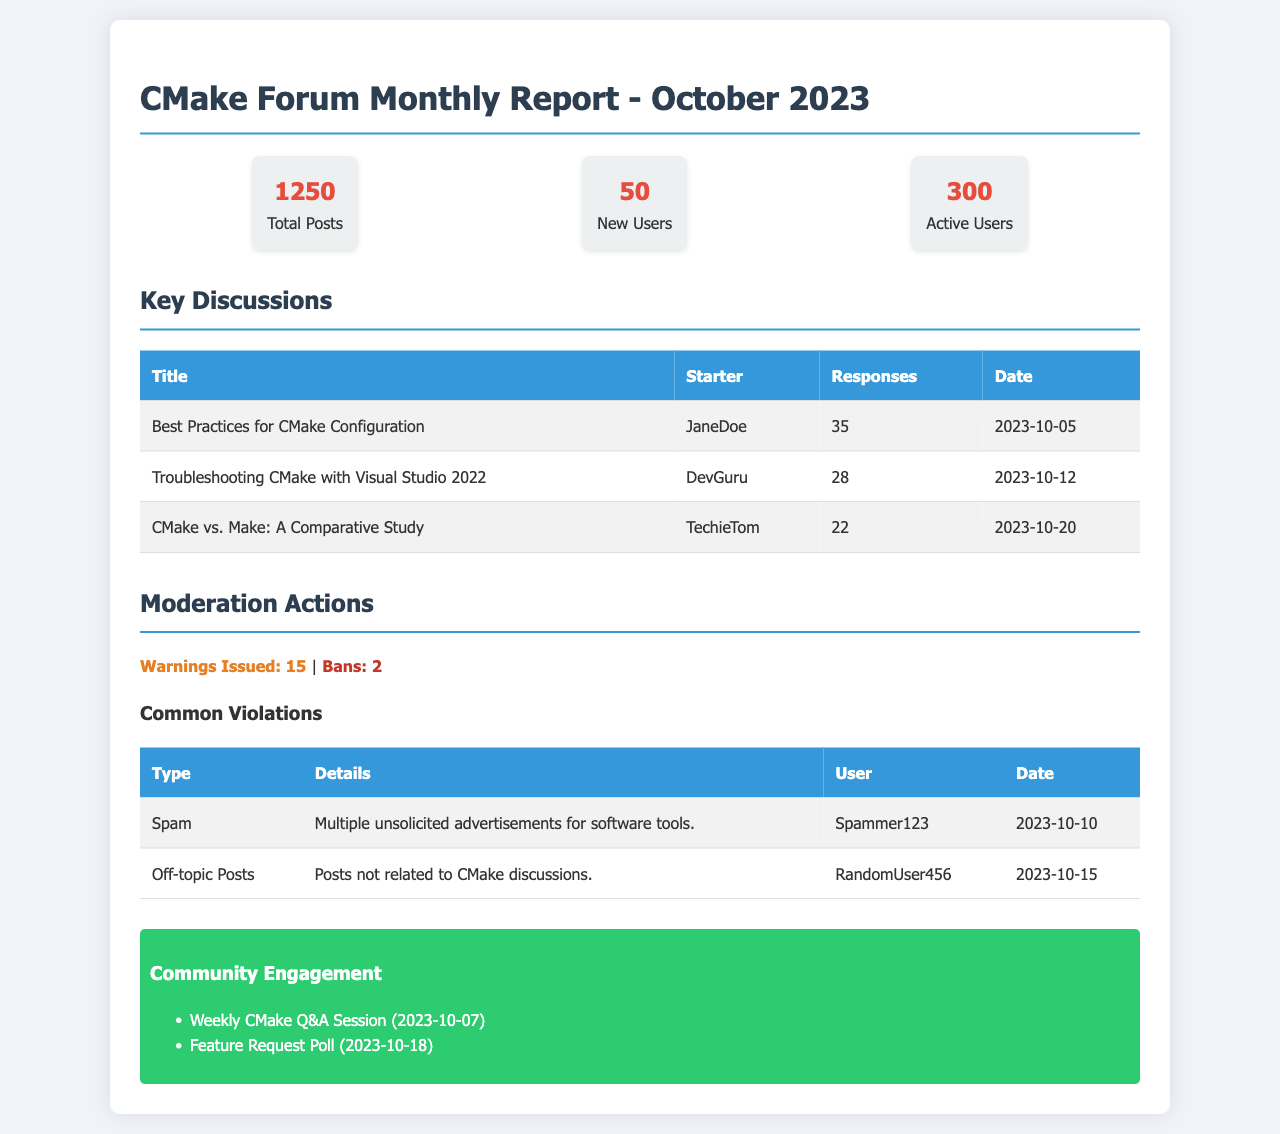What is the total number of posts? The total number of posts is stated in the statistics section of the document.
Answer: 1250 Who started the discussion titled "CMake vs. Make: A Comparative Study"? The title of the discussion and the user's name is provided in the key discussions table.
Answer: TechieTom How many new users joined in October 2023? The number of new users is indicated in the statistics section of the document.
Answer: 50 What type of violation led to the ban of two users? The violations are outlined in the moderation actions section, which includes listed user actions.
Answer: Spam What was the date of the "Troubleshooting CMake with Visual Studio 2022" discussion? The date is recorded in the key discussions table under the specific discussion title.
Answer: 2023-10-12 How many warnings were issued in October 2023? The number of warnings is specified in the moderation actions section of the document.
Answer: 15 What was the main topic of the weekly community engagement event on October 7? The engagement activities are listed in the community engagement section of the report.
Answer: Q&A Session Which user received a warning for off-topic posts? The details about who received warnings are available in the common violations table.
Answer: RandomUser456 